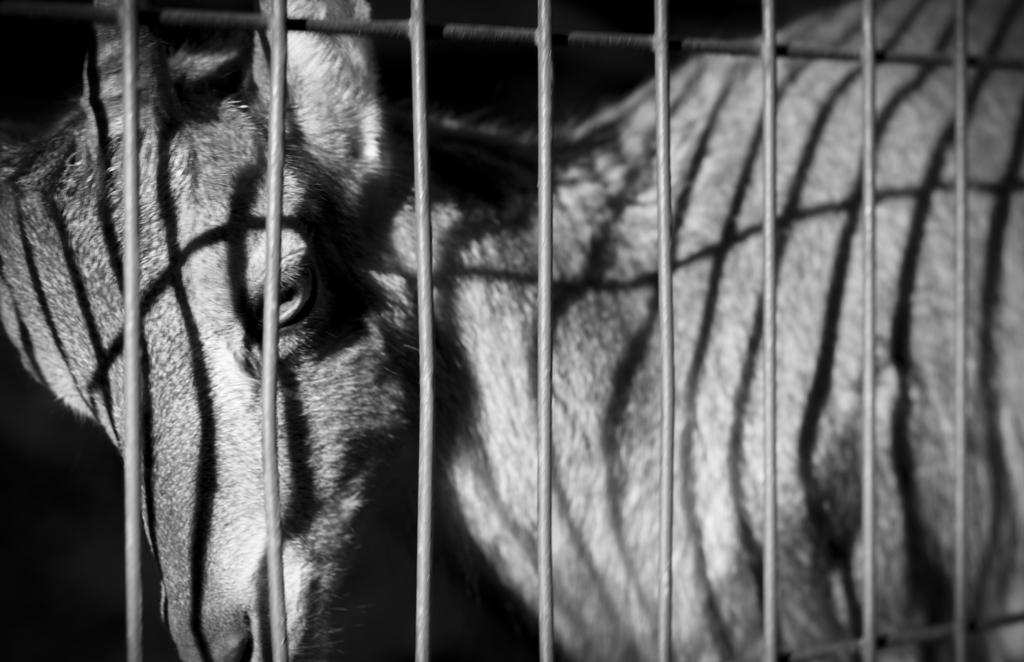What is the color scheme of the image? The image is black and white. What animal can be seen in the image? There is a deer in the image. Where is the deer located in relation to other objects in the image? The deer is behind grills. Can you tell me how many sugar cubes are on the deer's antlers in the image? There are no sugar cubes present in the image, and the deer's antlers are not visible. How many snakes are slithering around the deer in the image? There are no snakes present in the image; the deer is behind grills. 